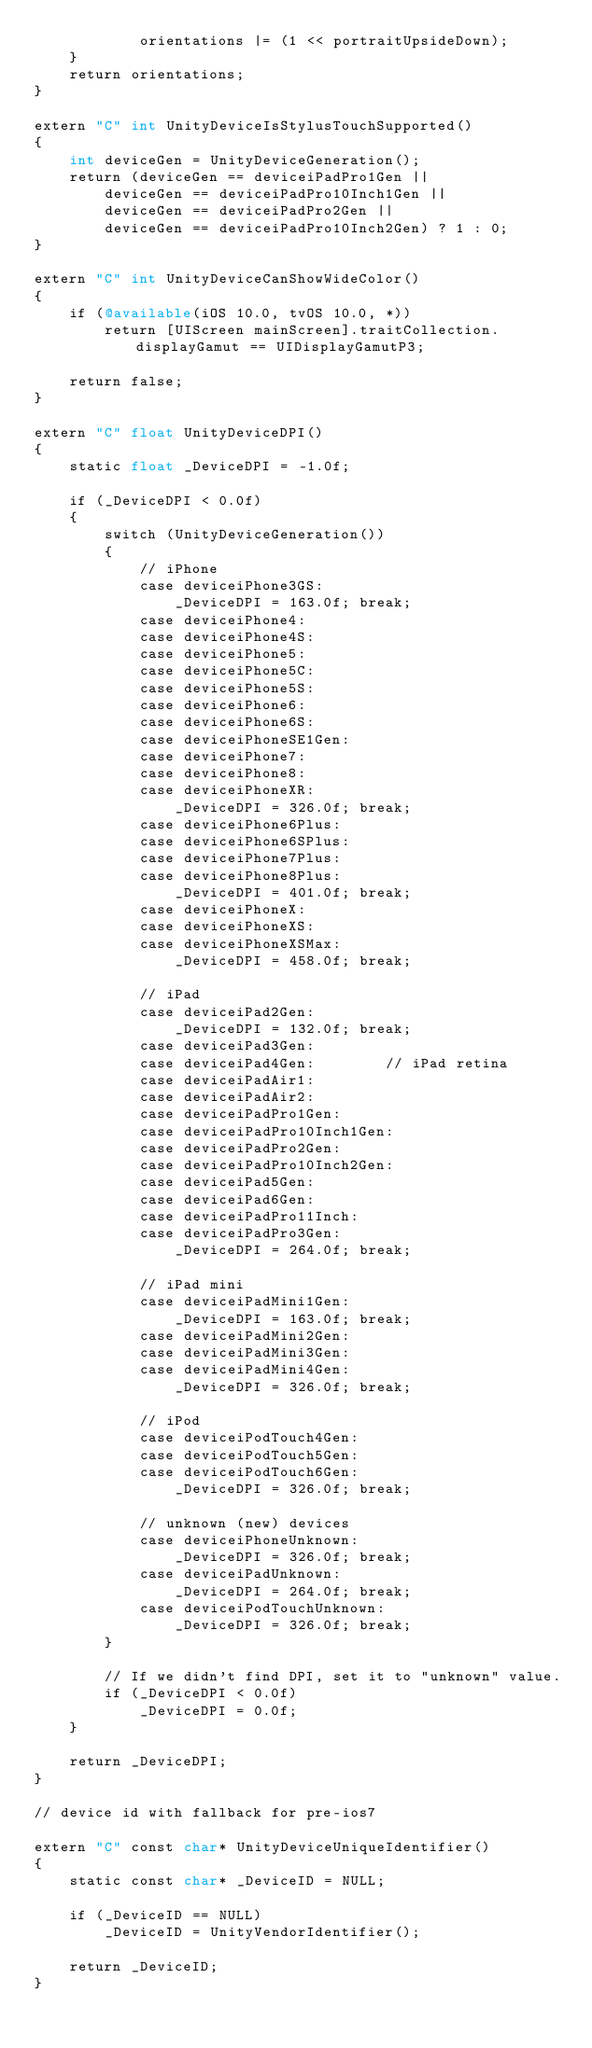Convert code to text. <code><loc_0><loc_0><loc_500><loc_500><_ObjectiveC_>            orientations |= (1 << portraitUpsideDown);
    }
    return orientations;
}

extern "C" int UnityDeviceIsStylusTouchSupported()
{
    int deviceGen = UnityDeviceGeneration();
    return (deviceGen == deviceiPadPro1Gen ||
        deviceGen == deviceiPadPro10Inch1Gen ||
        deviceGen == deviceiPadPro2Gen ||
        deviceGen == deviceiPadPro10Inch2Gen) ? 1 : 0;
}

extern "C" int UnityDeviceCanShowWideColor()
{
    if (@available(iOS 10.0, tvOS 10.0, *))
        return [UIScreen mainScreen].traitCollection.displayGamut == UIDisplayGamutP3;

    return false;
}

extern "C" float UnityDeviceDPI()
{
    static float _DeviceDPI = -1.0f;

    if (_DeviceDPI < 0.0f)
    {
        switch (UnityDeviceGeneration())
        {
            // iPhone
            case deviceiPhone3GS:
                _DeviceDPI = 163.0f; break;
            case deviceiPhone4:
            case deviceiPhone4S:
            case deviceiPhone5:
            case deviceiPhone5C:
            case deviceiPhone5S:
            case deviceiPhone6:
            case deviceiPhone6S:
            case deviceiPhoneSE1Gen:
            case deviceiPhone7:
            case deviceiPhone8:
            case deviceiPhoneXR:
                _DeviceDPI = 326.0f; break;
            case deviceiPhone6Plus:
            case deviceiPhone6SPlus:
            case deviceiPhone7Plus:
            case deviceiPhone8Plus:
                _DeviceDPI = 401.0f; break;
            case deviceiPhoneX:
            case deviceiPhoneXS:
            case deviceiPhoneXSMax:
                _DeviceDPI = 458.0f; break;

            // iPad
            case deviceiPad2Gen:
                _DeviceDPI = 132.0f; break;
            case deviceiPad3Gen:
            case deviceiPad4Gen:        // iPad retina
            case deviceiPadAir1:
            case deviceiPadAir2:
            case deviceiPadPro1Gen:
            case deviceiPadPro10Inch1Gen:
            case deviceiPadPro2Gen:
            case deviceiPadPro10Inch2Gen:
            case deviceiPad5Gen:
            case deviceiPad6Gen:
            case deviceiPadPro11Inch:
            case deviceiPadPro3Gen:
                _DeviceDPI = 264.0f; break;

            // iPad mini
            case deviceiPadMini1Gen:
                _DeviceDPI = 163.0f; break;
            case deviceiPadMini2Gen:
            case deviceiPadMini3Gen:
            case deviceiPadMini4Gen:
                _DeviceDPI = 326.0f; break;

            // iPod
            case deviceiPodTouch4Gen:
            case deviceiPodTouch5Gen:
            case deviceiPodTouch6Gen:
                _DeviceDPI = 326.0f; break;

            // unknown (new) devices
            case deviceiPhoneUnknown:
                _DeviceDPI = 326.0f; break;
            case deviceiPadUnknown:
                _DeviceDPI = 264.0f; break;
            case deviceiPodTouchUnknown:
                _DeviceDPI = 326.0f; break;
        }

        // If we didn't find DPI, set it to "unknown" value.
        if (_DeviceDPI < 0.0f)
            _DeviceDPI = 0.0f;
    }

    return _DeviceDPI;
}

// device id with fallback for pre-ios7

extern "C" const char* UnityDeviceUniqueIdentifier()
{
    static const char* _DeviceID = NULL;

    if (_DeviceID == NULL)
        _DeviceID = UnityVendorIdentifier();

    return _DeviceID;
}
</code> 